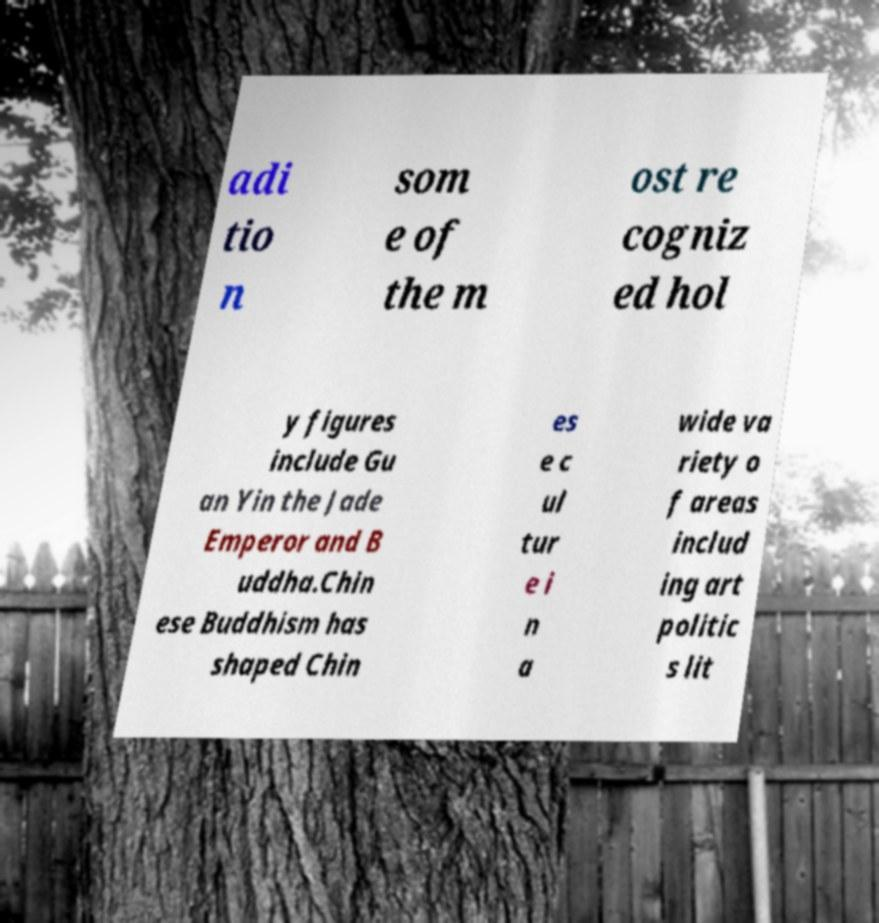Please read and relay the text visible in this image. What does it say? adi tio n som e of the m ost re cogniz ed hol y figures include Gu an Yin the Jade Emperor and B uddha.Chin ese Buddhism has shaped Chin es e c ul tur e i n a wide va riety o f areas includ ing art politic s lit 